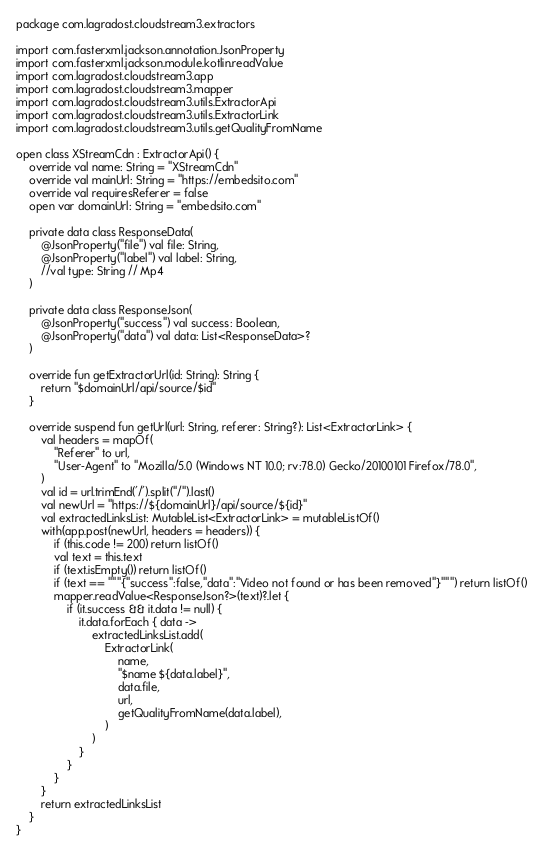Convert code to text. <code><loc_0><loc_0><loc_500><loc_500><_Kotlin_>package com.lagradost.cloudstream3.extractors

import com.fasterxml.jackson.annotation.JsonProperty
import com.fasterxml.jackson.module.kotlin.readValue
import com.lagradost.cloudstream3.app
import com.lagradost.cloudstream3.mapper
import com.lagradost.cloudstream3.utils.ExtractorApi
import com.lagradost.cloudstream3.utils.ExtractorLink
import com.lagradost.cloudstream3.utils.getQualityFromName

open class XStreamCdn : ExtractorApi() {
    override val name: String = "XStreamCdn"
    override val mainUrl: String = "https://embedsito.com"
    override val requiresReferer = false
    open var domainUrl: String = "embedsito.com"

    private data class ResponseData(
        @JsonProperty("file") val file: String,
        @JsonProperty("label") val label: String,
        //val type: String // Mp4
    )

    private data class ResponseJson(
        @JsonProperty("success") val success: Boolean,
        @JsonProperty("data") val data: List<ResponseData>?
    )

    override fun getExtractorUrl(id: String): String {
        return "$domainUrl/api/source/$id"
    }

    override suspend fun getUrl(url: String, referer: String?): List<ExtractorLink> {
        val headers = mapOf(
            "Referer" to url,
            "User-Agent" to "Mozilla/5.0 (Windows NT 10.0; rv:78.0) Gecko/20100101 Firefox/78.0",
        )
        val id = url.trimEnd('/').split("/").last()
        val newUrl = "https://${domainUrl}/api/source/${id}"
        val extractedLinksList: MutableList<ExtractorLink> = mutableListOf()
        with(app.post(newUrl, headers = headers)) {
            if (this.code != 200) return listOf()
            val text = this.text
            if (text.isEmpty()) return listOf()
            if (text == """{"success":false,"data":"Video not found or has been removed"}""") return listOf()
            mapper.readValue<ResponseJson?>(text)?.let {
                if (it.success && it.data != null) {
                    it.data.forEach { data ->
                        extractedLinksList.add(
                            ExtractorLink(
                                name,
                                "$name ${data.label}",
                                data.file,
                                url,
                                getQualityFromName(data.label),
                            )
                        )
                    }
                }
            }
        }
        return extractedLinksList
    }
}</code> 